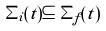Convert formula to latex. <formula><loc_0><loc_0><loc_500><loc_500>\Sigma _ { i } ( t ) \subseteq \Sigma _ { f } ( t )</formula> 